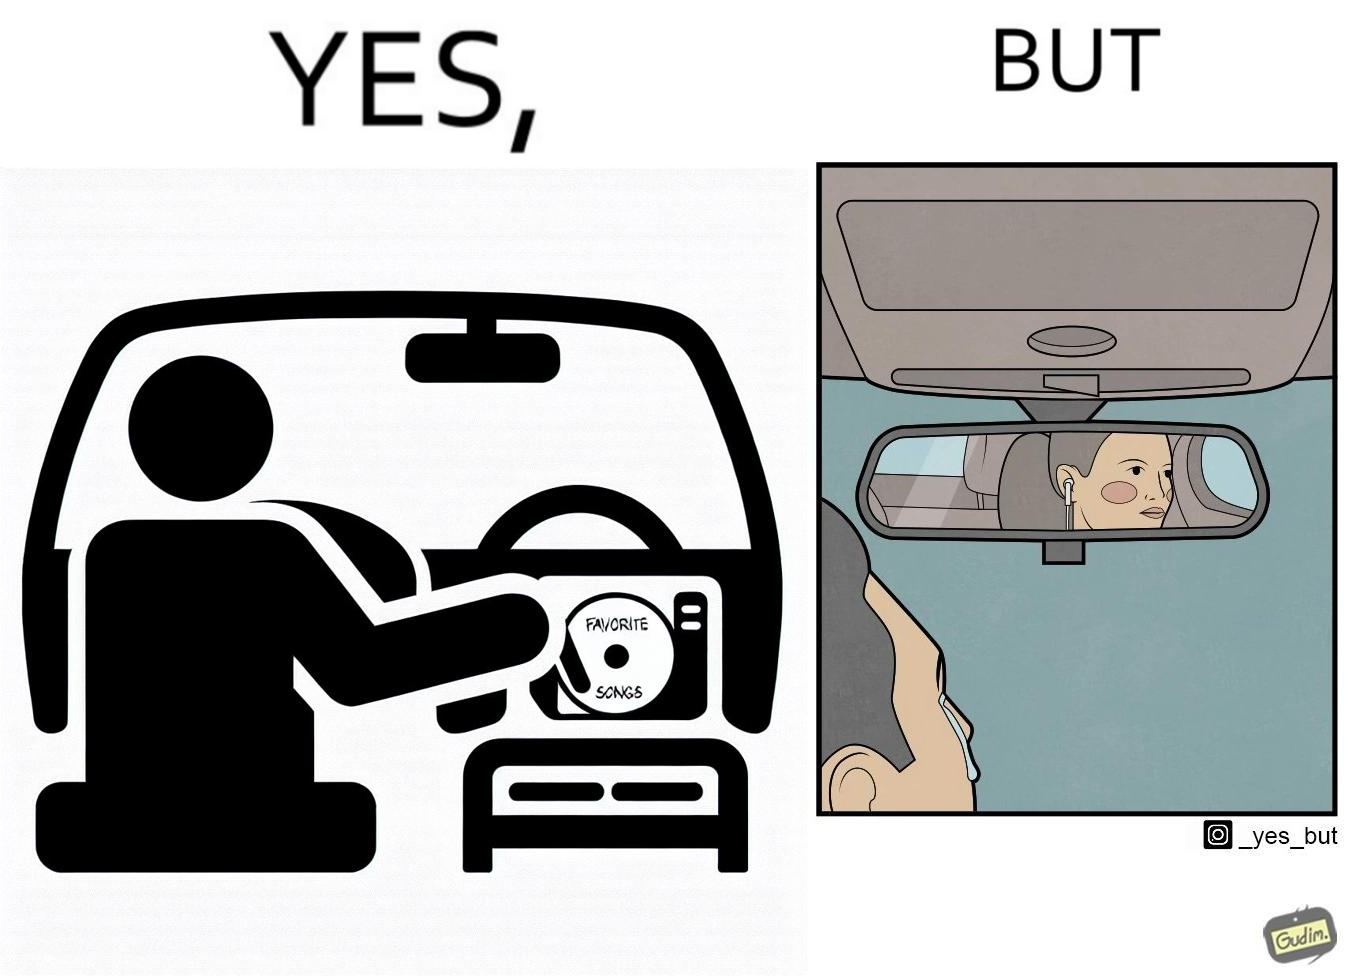Compare the left and right sides of this image. In the left part of the image: a person in the driving seat is inserting a CD with "Favorite Songs" written on it into the CD player of a car dashboard. In the right part of the image: driver of the car is sad on seeing the person (on the rear view mirror) sitting in the back seat of the car wearing earphones. 